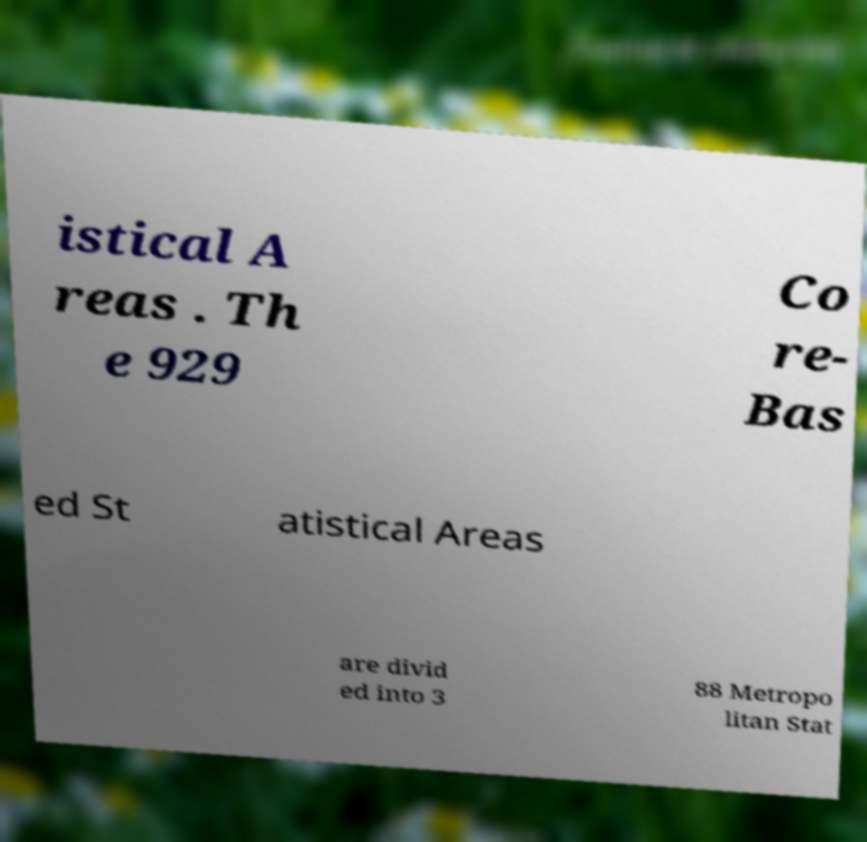Can you read and provide the text displayed in the image?This photo seems to have some interesting text. Can you extract and type it out for me? istical A reas . Th e 929 Co re- Bas ed St atistical Areas are divid ed into 3 88 Metropo litan Stat 